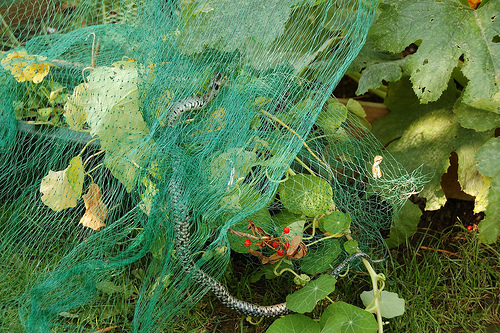<image>
Can you confirm if the leaf is behind the rope? Yes. From this viewpoint, the leaf is positioned behind the rope, with the rope partially or fully occluding the leaf. 